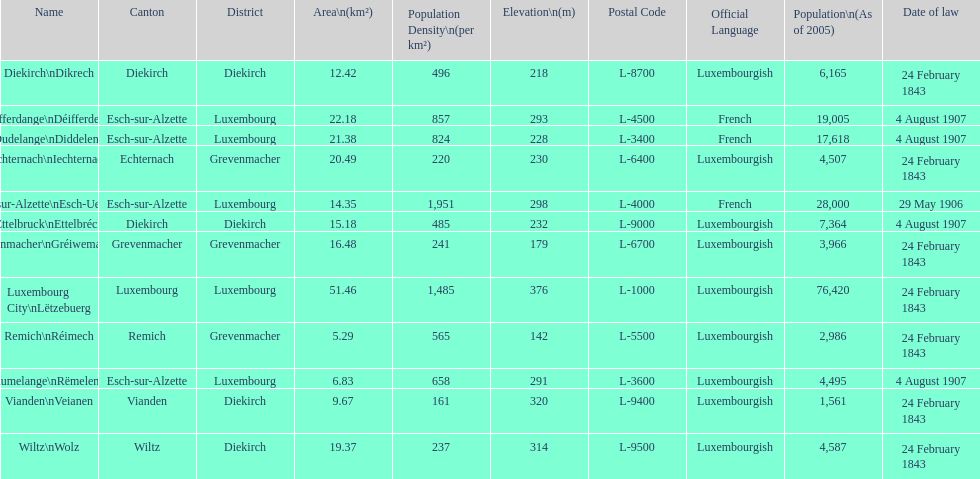Could you parse the entire table as a dict? {'header': ['Name', 'Canton', 'District', 'Area\\n(km²)', 'Population Density\\n(per km²)', 'Elevation\\n(m)', 'Postal Code', 'Official Language', 'Population\\n(As of 2005)', 'Date of law'], 'rows': [['Diekirch\\nDikrech', 'Diekirch', 'Diekirch', '12.42', '496', '218', 'L-8700', 'Luxembourgish', '6,165', '24 February 1843'], ['Differdange\\nDéifferdeng', 'Esch-sur-Alzette', 'Luxembourg', '22.18', '857', '293', 'L-4500', 'French', '19,005', '4 August 1907'], ['Dudelange\\nDiddeleng', 'Esch-sur-Alzette', 'Luxembourg', '21.38', '824', '228', 'L-3400', 'French', '17,618', '4 August 1907'], ['Echternach\\nIechternach', 'Echternach', 'Grevenmacher', '20.49', '220', '230', 'L-6400', 'Luxembourgish', '4,507', '24 February 1843'], ['Esch-sur-Alzette\\nEsch-Uelzecht', 'Esch-sur-Alzette', 'Luxembourg', '14.35', '1,951', '298', 'L-4000', 'French', '28,000', '29 May 1906'], ['Ettelbruck\\nEttelbréck', 'Diekirch', 'Diekirch', '15.18', '485', '232', 'L-9000', 'Luxembourgish', '7,364', '4 August 1907'], ['Grevenmacher\\nGréiwemaacher', 'Grevenmacher', 'Grevenmacher', '16.48', '241', '179', 'L-6700', 'Luxembourgish', '3,966', '24 February 1843'], ['Luxembourg City\\nLëtzebuerg', 'Luxembourg', 'Luxembourg', '51.46', '1,485', '376', 'L-1000', 'Luxembourgish', '76,420', '24 February 1843'], ['Remich\\nRéimech', 'Remich', 'Grevenmacher', '5.29', '565', '142', 'L-5500', 'Luxembourgish', '2,986', '24 February 1843'], ['Rumelange\\nRëmeleng', 'Esch-sur-Alzette', 'Luxembourg', '6.83', '658', '291', 'L-3600', 'Luxembourgish', '4,495', '4 August 1907'], ['Vianden\\nVeianen', 'Vianden', 'Diekirch', '9.67', '161', '320', 'L-9400', 'Luxembourgish', '1,561', '24 February 1843'], ['Wiltz\\nWolz', 'Wiltz', 'Diekirch', '19.37', '237', '314', 'L-9500', 'Luxembourgish', '4,587', '24 February 1843']]} How many diekirch districts also have diekirch as their canton? 2. 